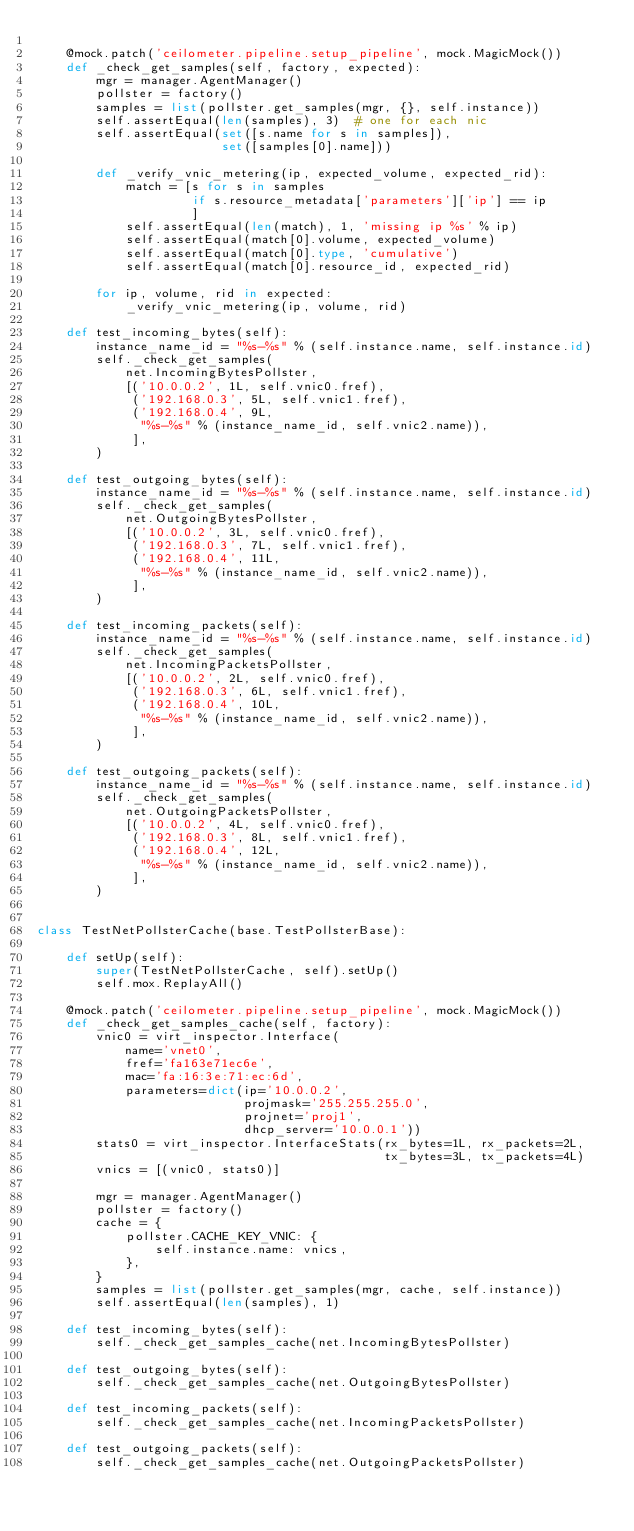<code> <loc_0><loc_0><loc_500><loc_500><_Python_>
    @mock.patch('ceilometer.pipeline.setup_pipeline', mock.MagicMock())
    def _check_get_samples(self, factory, expected):
        mgr = manager.AgentManager()
        pollster = factory()
        samples = list(pollster.get_samples(mgr, {}, self.instance))
        self.assertEqual(len(samples), 3)  # one for each nic
        self.assertEqual(set([s.name for s in samples]),
                         set([samples[0].name]))

        def _verify_vnic_metering(ip, expected_volume, expected_rid):
            match = [s for s in samples
                     if s.resource_metadata['parameters']['ip'] == ip
                     ]
            self.assertEqual(len(match), 1, 'missing ip %s' % ip)
            self.assertEqual(match[0].volume, expected_volume)
            self.assertEqual(match[0].type, 'cumulative')
            self.assertEqual(match[0].resource_id, expected_rid)

        for ip, volume, rid in expected:
            _verify_vnic_metering(ip, volume, rid)

    def test_incoming_bytes(self):
        instance_name_id = "%s-%s" % (self.instance.name, self.instance.id)
        self._check_get_samples(
            net.IncomingBytesPollster,
            [('10.0.0.2', 1L, self.vnic0.fref),
             ('192.168.0.3', 5L, self.vnic1.fref),
             ('192.168.0.4', 9L,
              "%s-%s" % (instance_name_id, self.vnic2.name)),
             ],
        )

    def test_outgoing_bytes(self):
        instance_name_id = "%s-%s" % (self.instance.name, self.instance.id)
        self._check_get_samples(
            net.OutgoingBytesPollster,
            [('10.0.0.2', 3L, self.vnic0.fref),
             ('192.168.0.3', 7L, self.vnic1.fref),
             ('192.168.0.4', 11L,
              "%s-%s" % (instance_name_id, self.vnic2.name)),
             ],
        )

    def test_incoming_packets(self):
        instance_name_id = "%s-%s" % (self.instance.name, self.instance.id)
        self._check_get_samples(
            net.IncomingPacketsPollster,
            [('10.0.0.2', 2L, self.vnic0.fref),
             ('192.168.0.3', 6L, self.vnic1.fref),
             ('192.168.0.4', 10L,
              "%s-%s" % (instance_name_id, self.vnic2.name)),
             ],
        )

    def test_outgoing_packets(self):
        instance_name_id = "%s-%s" % (self.instance.name, self.instance.id)
        self._check_get_samples(
            net.OutgoingPacketsPollster,
            [('10.0.0.2', 4L, self.vnic0.fref),
             ('192.168.0.3', 8L, self.vnic1.fref),
             ('192.168.0.4', 12L,
              "%s-%s" % (instance_name_id, self.vnic2.name)),
             ],
        )


class TestNetPollsterCache(base.TestPollsterBase):

    def setUp(self):
        super(TestNetPollsterCache, self).setUp()
        self.mox.ReplayAll()

    @mock.patch('ceilometer.pipeline.setup_pipeline', mock.MagicMock())
    def _check_get_samples_cache(self, factory):
        vnic0 = virt_inspector.Interface(
            name='vnet0',
            fref='fa163e71ec6e',
            mac='fa:16:3e:71:ec:6d',
            parameters=dict(ip='10.0.0.2',
                            projmask='255.255.255.0',
                            projnet='proj1',
                            dhcp_server='10.0.0.1'))
        stats0 = virt_inspector.InterfaceStats(rx_bytes=1L, rx_packets=2L,
                                               tx_bytes=3L, tx_packets=4L)
        vnics = [(vnic0, stats0)]

        mgr = manager.AgentManager()
        pollster = factory()
        cache = {
            pollster.CACHE_KEY_VNIC: {
                self.instance.name: vnics,
            },
        }
        samples = list(pollster.get_samples(mgr, cache, self.instance))
        self.assertEqual(len(samples), 1)

    def test_incoming_bytes(self):
        self._check_get_samples_cache(net.IncomingBytesPollster)

    def test_outgoing_bytes(self):
        self._check_get_samples_cache(net.OutgoingBytesPollster)

    def test_incoming_packets(self):
        self._check_get_samples_cache(net.IncomingPacketsPollster)

    def test_outgoing_packets(self):
        self._check_get_samples_cache(net.OutgoingPacketsPollster)
</code> 